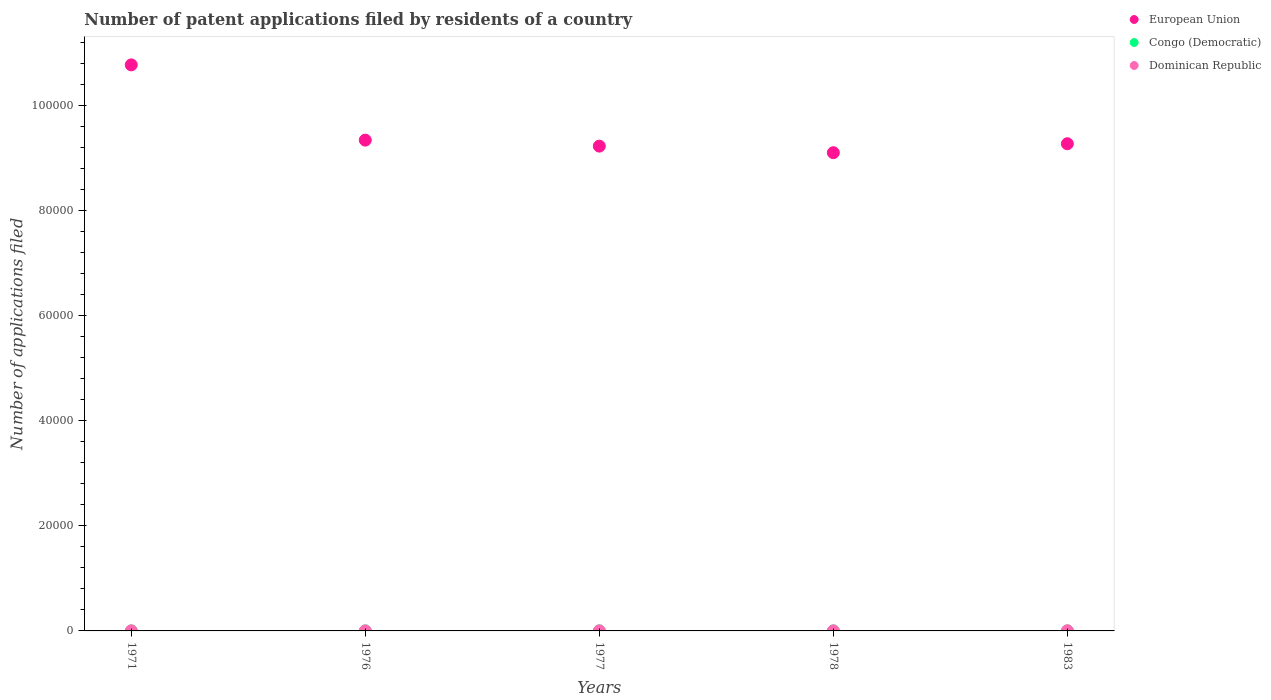Is the number of dotlines equal to the number of legend labels?
Offer a terse response. Yes. What is the number of applications filed in European Union in 1976?
Make the answer very short. 9.34e+04. Across all years, what is the maximum number of applications filed in Congo (Democratic)?
Offer a very short reply. 6. Across all years, what is the minimum number of applications filed in European Union?
Your response must be concise. 9.10e+04. In which year was the number of applications filed in European Union maximum?
Your answer should be very brief. 1971. In which year was the number of applications filed in Congo (Democratic) minimum?
Your answer should be very brief. 1971. What is the total number of applications filed in European Union in the graph?
Your response must be concise. 4.77e+05. What is the difference between the number of applications filed in European Union in 1978 and the number of applications filed in Dominican Republic in 1976?
Provide a succinct answer. 9.10e+04. What is the average number of applications filed in Dominican Republic per year?
Offer a very short reply. 12.4. In the year 1977, what is the difference between the number of applications filed in European Union and number of applications filed in Dominican Republic?
Your answer should be compact. 9.22e+04. In how many years, is the number of applications filed in European Union greater than 48000?
Your response must be concise. 5. What is the ratio of the number of applications filed in European Union in 1971 to that in 1977?
Ensure brevity in your answer.  1.17. Is the difference between the number of applications filed in European Union in 1971 and 1978 greater than the difference between the number of applications filed in Dominican Republic in 1971 and 1978?
Make the answer very short. Yes. What is the difference between the highest and the lowest number of applications filed in European Union?
Offer a terse response. 1.67e+04. In how many years, is the number of applications filed in Dominican Republic greater than the average number of applications filed in Dominican Republic taken over all years?
Make the answer very short. 1. Is the sum of the number of applications filed in Dominican Republic in 1971 and 1976 greater than the maximum number of applications filed in European Union across all years?
Your answer should be very brief. No. Does the number of applications filed in Dominican Republic monotonically increase over the years?
Keep it short and to the point. No. Is the number of applications filed in Dominican Republic strictly greater than the number of applications filed in European Union over the years?
Provide a short and direct response. No. Is the number of applications filed in European Union strictly less than the number of applications filed in Congo (Democratic) over the years?
Make the answer very short. No. How many years are there in the graph?
Your answer should be compact. 5. Does the graph contain any zero values?
Give a very brief answer. No. Where does the legend appear in the graph?
Your answer should be compact. Top right. How are the legend labels stacked?
Your answer should be compact. Vertical. What is the title of the graph?
Give a very brief answer. Number of patent applications filed by residents of a country. Does "Afghanistan" appear as one of the legend labels in the graph?
Offer a very short reply. No. What is the label or title of the X-axis?
Provide a succinct answer. Years. What is the label or title of the Y-axis?
Your answer should be very brief. Number of applications filed. What is the Number of applications filed in European Union in 1971?
Your answer should be very brief. 1.08e+05. What is the Number of applications filed in Congo (Democratic) in 1971?
Your answer should be very brief. 1. What is the Number of applications filed of European Union in 1976?
Keep it short and to the point. 9.34e+04. What is the Number of applications filed in Congo (Democratic) in 1976?
Keep it short and to the point. 2. What is the Number of applications filed of European Union in 1977?
Make the answer very short. 9.22e+04. What is the Number of applications filed in Congo (Democratic) in 1977?
Your answer should be very brief. 4. What is the Number of applications filed of Dominican Republic in 1977?
Your answer should be compact. 9. What is the Number of applications filed in European Union in 1978?
Offer a terse response. 9.10e+04. What is the Number of applications filed in Congo (Democratic) in 1978?
Provide a short and direct response. 3. What is the Number of applications filed of European Union in 1983?
Offer a very short reply. 9.27e+04. What is the Number of applications filed in Congo (Democratic) in 1983?
Offer a terse response. 6. What is the Number of applications filed in Dominican Republic in 1983?
Offer a terse response. 25. Across all years, what is the maximum Number of applications filed of European Union?
Give a very brief answer. 1.08e+05. Across all years, what is the maximum Number of applications filed in Congo (Democratic)?
Provide a short and direct response. 6. Across all years, what is the maximum Number of applications filed in Dominican Republic?
Offer a terse response. 25. Across all years, what is the minimum Number of applications filed in European Union?
Provide a short and direct response. 9.10e+04. What is the total Number of applications filed in European Union in the graph?
Provide a short and direct response. 4.77e+05. What is the total Number of applications filed in Congo (Democratic) in the graph?
Your answer should be compact. 16. What is the total Number of applications filed of Dominican Republic in the graph?
Provide a short and direct response. 62. What is the difference between the Number of applications filed in European Union in 1971 and that in 1976?
Offer a very short reply. 1.43e+04. What is the difference between the Number of applications filed in European Union in 1971 and that in 1977?
Offer a very short reply. 1.55e+04. What is the difference between the Number of applications filed of Congo (Democratic) in 1971 and that in 1977?
Offer a very short reply. -3. What is the difference between the Number of applications filed in Dominican Republic in 1971 and that in 1977?
Provide a short and direct response. 2. What is the difference between the Number of applications filed in European Union in 1971 and that in 1978?
Ensure brevity in your answer.  1.67e+04. What is the difference between the Number of applications filed in Congo (Democratic) in 1971 and that in 1978?
Give a very brief answer. -2. What is the difference between the Number of applications filed of European Union in 1971 and that in 1983?
Provide a short and direct response. 1.50e+04. What is the difference between the Number of applications filed of Congo (Democratic) in 1971 and that in 1983?
Give a very brief answer. -5. What is the difference between the Number of applications filed of Dominican Republic in 1971 and that in 1983?
Your answer should be compact. -14. What is the difference between the Number of applications filed in European Union in 1976 and that in 1977?
Your answer should be very brief. 1142. What is the difference between the Number of applications filed in Congo (Democratic) in 1976 and that in 1977?
Offer a very short reply. -2. What is the difference between the Number of applications filed of Dominican Republic in 1976 and that in 1977?
Your answer should be compact. -2. What is the difference between the Number of applications filed in European Union in 1976 and that in 1978?
Your response must be concise. 2393. What is the difference between the Number of applications filed of Dominican Republic in 1976 and that in 1978?
Your answer should be compact. -3. What is the difference between the Number of applications filed of European Union in 1976 and that in 1983?
Your response must be concise. 690. What is the difference between the Number of applications filed of European Union in 1977 and that in 1978?
Make the answer very short. 1251. What is the difference between the Number of applications filed of Congo (Democratic) in 1977 and that in 1978?
Your answer should be very brief. 1. What is the difference between the Number of applications filed in Dominican Republic in 1977 and that in 1978?
Offer a very short reply. -1. What is the difference between the Number of applications filed of European Union in 1977 and that in 1983?
Your response must be concise. -452. What is the difference between the Number of applications filed of Congo (Democratic) in 1977 and that in 1983?
Ensure brevity in your answer.  -2. What is the difference between the Number of applications filed of European Union in 1978 and that in 1983?
Ensure brevity in your answer.  -1703. What is the difference between the Number of applications filed of European Union in 1971 and the Number of applications filed of Congo (Democratic) in 1976?
Provide a succinct answer. 1.08e+05. What is the difference between the Number of applications filed in European Union in 1971 and the Number of applications filed in Dominican Republic in 1976?
Your answer should be compact. 1.08e+05. What is the difference between the Number of applications filed in Congo (Democratic) in 1971 and the Number of applications filed in Dominican Republic in 1976?
Offer a terse response. -6. What is the difference between the Number of applications filed of European Union in 1971 and the Number of applications filed of Congo (Democratic) in 1977?
Keep it short and to the point. 1.08e+05. What is the difference between the Number of applications filed of European Union in 1971 and the Number of applications filed of Dominican Republic in 1977?
Make the answer very short. 1.08e+05. What is the difference between the Number of applications filed in European Union in 1971 and the Number of applications filed in Congo (Democratic) in 1978?
Make the answer very short. 1.08e+05. What is the difference between the Number of applications filed of European Union in 1971 and the Number of applications filed of Dominican Republic in 1978?
Offer a very short reply. 1.08e+05. What is the difference between the Number of applications filed in European Union in 1971 and the Number of applications filed in Congo (Democratic) in 1983?
Provide a short and direct response. 1.08e+05. What is the difference between the Number of applications filed of European Union in 1971 and the Number of applications filed of Dominican Republic in 1983?
Give a very brief answer. 1.08e+05. What is the difference between the Number of applications filed in European Union in 1976 and the Number of applications filed in Congo (Democratic) in 1977?
Provide a short and direct response. 9.34e+04. What is the difference between the Number of applications filed in European Union in 1976 and the Number of applications filed in Dominican Republic in 1977?
Your answer should be compact. 9.34e+04. What is the difference between the Number of applications filed in Congo (Democratic) in 1976 and the Number of applications filed in Dominican Republic in 1977?
Provide a succinct answer. -7. What is the difference between the Number of applications filed in European Union in 1976 and the Number of applications filed in Congo (Democratic) in 1978?
Ensure brevity in your answer.  9.34e+04. What is the difference between the Number of applications filed of European Union in 1976 and the Number of applications filed of Dominican Republic in 1978?
Your answer should be compact. 9.34e+04. What is the difference between the Number of applications filed in European Union in 1976 and the Number of applications filed in Congo (Democratic) in 1983?
Offer a terse response. 9.34e+04. What is the difference between the Number of applications filed in European Union in 1976 and the Number of applications filed in Dominican Republic in 1983?
Provide a succinct answer. 9.33e+04. What is the difference between the Number of applications filed of Congo (Democratic) in 1976 and the Number of applications filed of Dominican Republic in 1983?
Provide a short and direct response. -23. What is the difference between the Number of applications filed in European Union in 1977 and the Number of applications filed in Congo (Democratic) in 1978?
Make the answer very short. 9.22e+04. What is the difference between the Number of applications filed in European Union in 1977 and the Number of applications filed in Dominican Republic in 1978?
Provide a succinct answer. 9.22e+04. What is the difference between the Number of applications filed of European Union in 1977 and the Number of applications filed of Congo (Democratic) in 1983?
Your response must be concise. 9.22e+04. What is the difference between the Number of applications filed of European Union in 1977 and the Number of applications filed of Dominican Republic in 1983?
Provide a short and direct response. 9.22e+04. What is the difference between the Number of applications filed of European Union in 1978 and the Number of applications filed of Congo (Democratic) in 1983?
Offer a terse response. 9.10e+04. What is the difference between the Number of applications filed of European Union in 1978 and the Number of applications filed of Dominican Republic in 1983?
Your response must be concise. 9.10e+04. What is the average Number of applications filed of European Union per year?
Provide a succinct answer. 9.54e+04. What is the average Number of applications filed in Dominican Republic per year?
Keep it short and to the point. 12.4. In the year 1971, what is the difference between the Number of applications filed in European Union and Number of applications filed in Congo (Democratic)?
Offer a very short reply. 1.08e+05. In the year 1971, what is the difference between the Number of applications filed in European Union and Number of applications filed in Dominican Republic?
Make the answer very short. 1.08e+05. In the year 1976, what is the difference between the Number of applications filed of European Union and Number of applications filed of Congo (Democratic)?
Your answer should be very brief. 9.34e+04. In the year 1976, what is the difference between the Number of applications filed of European Union and Number of applications filed of Dominican Republic?
Ensure brevity in your answer.  9.34e+04. In the year 1976, what is the difference between the Number of applications filed of Congo (Democratic) and Number of applications filed of Dominican Republic?
Offer a very short reply. -5. In the year 1977, what is the difference between the Number of applications filed in European Union and Number of applications filed in Congo (Democratic)?
Your answer should be compact. 9.22e+04. In the year 1977, what is the difference between the Number of applications filed in European Union and Number of applications filed in Dominican Republic?
Provide a succinct answer. 9.22e+04. In the year 1977, what is the difference between the Number of applications filed of Congo (Democratic) and Number of applications filed of Dominican Republic?
Your answer should be compact. -5. In the year 1978, what is the difference between the Number of applications filed of European Union and Number of applications filed of Congo (Democratic)?
Offer a very short reply. 9.10e+04. In the year 1978, what is the difference between the Number of applications filed in European Union and Number of applications filed in Dominican Republic?
Provide a short and direct response. 9.10e+04. In the year 1978, what is the difference between the Number of applications filed in Congo (Democratic) and Number of applications filed in Dominican Republic?
Make the answer very short. -7. In the year 1983, what is the difference between the Number of applications filed of European Union and Number of applications filed of Congo (Democratic)?
Provide a succinct answer. 9.27e+04. In the year 1983, what is the difference between the Number of applications filed of European Union and Number of applications filed of Dominican Republic?
Give a very brief answer. 9.27e+04. What is the ratio of the Number of applications filed in European Union in 1971 to that in 1976?
Offer a very short reply. 1.15. What is the ratio of the Number of applications filed in Congo (Democratic) in 1971 to that in 1976?
Provide a short and direct response. 0.5. What is the ratio of the Number of applications filed of Dominican Republic in 1971 to that in 1976?
Your response must be concise. 1.57. What is the ratio of the Number of applications filed of European Union in 1971 to that in 1977?
Your answer should be very brief. 1.17. What is the ratio of the Number of applications filed in Dominican Republic in 1971 to that in 1977?
Your answer should be compact. 1.22. What is the ratio of the Number of applications filed of European Union in 1971 to that in 1978?
Provide a succinct answer. 1.18. What is the ratio of the Number of applications filed of Congo (Democratic) in 1971 to that in 1978?
Make the answer very short. 0.33. What is the ratio of the Number of applications filed in Dominican Republic in 1971 to that in 1978?
Offer a terse response. 1.1. What is the ratio of the Number of applications filed in European Union in 1971 to that in 1983?
Provide a succinct answer. 1.16. What is the ratio of the Number of applications filed of Congo (Democratic) in 1971 to that in 1983?
Your response must be concise. 0.17. What is the ratio of the Number of applications filed of Dominican Republic in 1971 to that in 1983?
Offer a very short reply. 0.44. What is the ratio of the Number of applications filed in European Union in 1976 to that in 1977?
Ensure brevity in your answer.  1.01. What is the ratio of the Number of applications filed of Congo (Democratic) in 1976 to that in 1977?
Ensure brevity in your answer.  0.5. What is the ratio of the Number of applications filed in Dominican Republic in 1976 to that in 1977?
Give a very brief answer. 0.78. What is the ratio of the Number of applications filed of European Union in 1976 to that in 1978?
Your response must be concise. 1.03. What is the ratio of the Number of applications filed of European Union in 1976 to that in 1983?
Give a very brief answer. 1.01. What is the ratio of the Number of applications filed of Dominican Republic in 1976 to that in 1983?
Your answer should be compact. 0.28. What is the ratio of the Number of applications filed of European Union in 1977 to that in 1978?
Provide a succinct answer. 1.01. What is the ratio of the Number of applications filed in Congo (Democratic) in 1977 to that in 1978?
Your response must be concise. 1.33. What is the ratio of the Number of applications filed of Dominican Republic in 1977 to that in 1983?
Offer a terse response. 0.36. What is the ratio of the Number of applications filed in European Union in 1978 to that in 1983?
Make the answer very short. 0.98. What is the ratio of the Number of applications filed in Congo (Democratic) in 1978 to that in 1983?
Offer a terse response. 0.5. What is the ratio of the Number of applications filed of Dominican Republic in 1978 to that in 1983?
Offer a terse response. 0.4. What is the difference between the highest and the second highest Number of applications filed in European Union?
Provide a short and direct response. 1.43e+04. What is the difference between the highest and the second highest Number of applications filed in Dominican Republic?
Provide a short and direct response. 14. What is the difference between the highest and the lowest Number of applications filed in European Union?
Keep it short and to the point. 1.67e+04. 